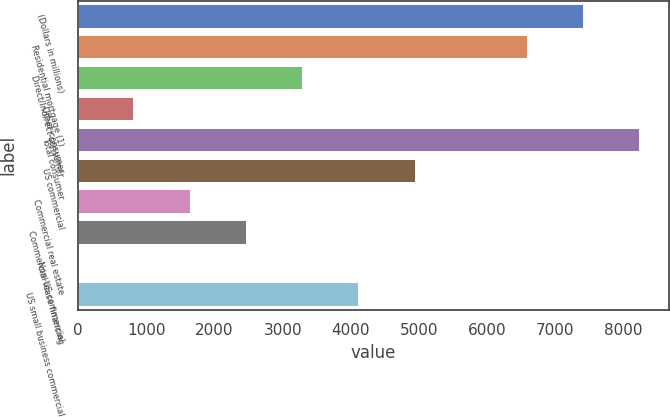<chart> <loc_0><loc_0><loc_500><loc_500><bar_chart><fcel>(Dollars in millions)<fcel>Residential mortgage (1)<fcel>Direct/Indirect consumer<fcel>Other consumer<fcel>Total consumer<fcel>US commercial<fcel>Commercial real estate<fcel>Commercial lease financing<fcel>Non-US commercial<fcel>US small business commercial<nl><fcel>7425.1<fcel>6600.2<fcel>3300.6<fcel>825.9<fcel>8250<fcel>4950.4<fcel>1650.8<fcel>2475.7<fcel>1<fcel>4125.5<nl></chart> 